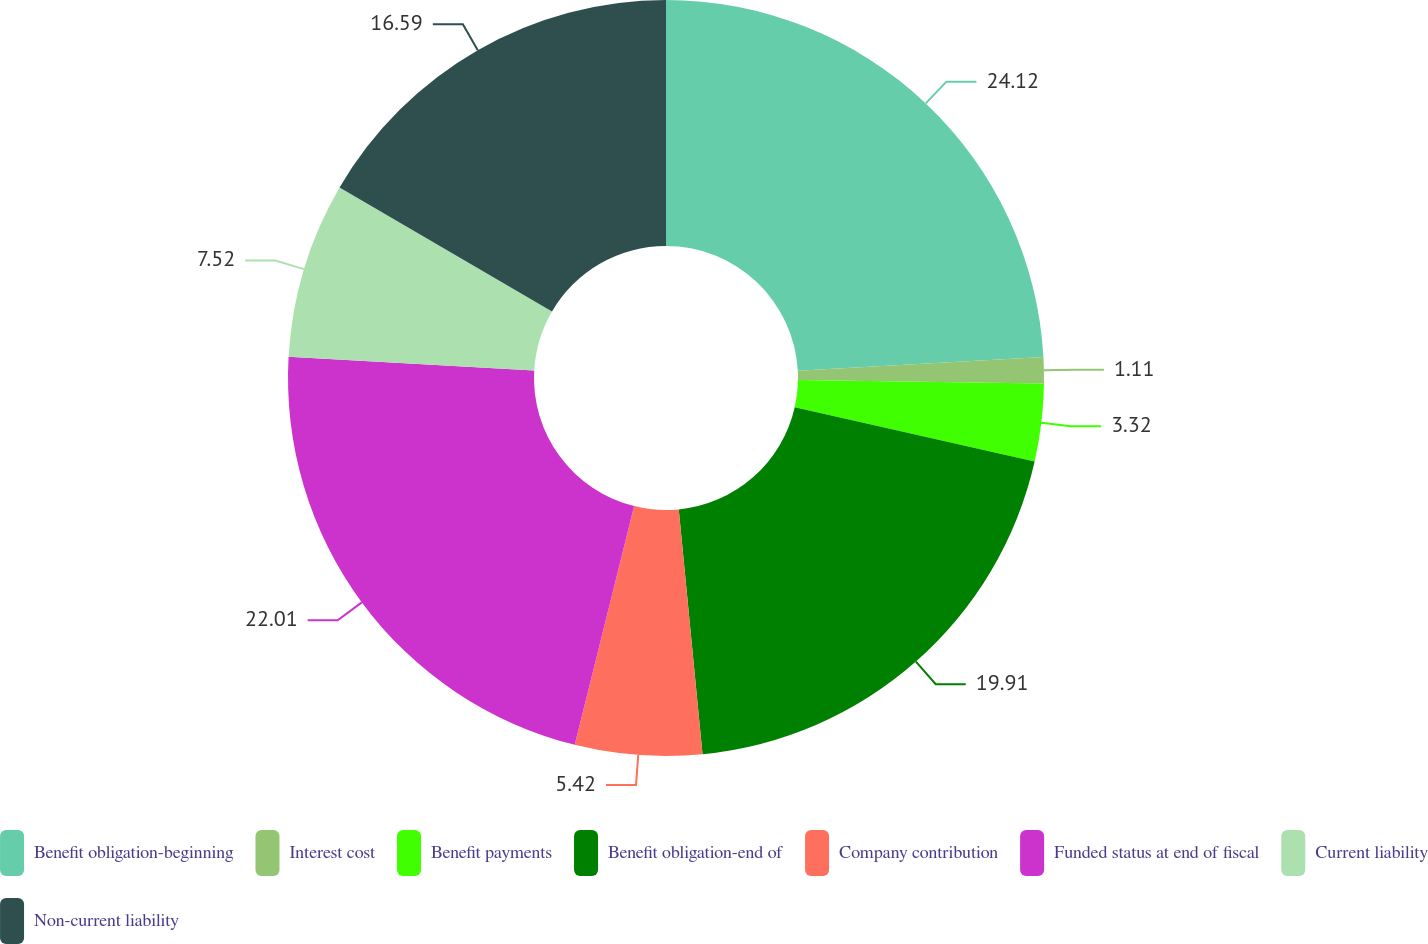Convert chart to OTSL. <chart><loc_0><loc_0><loc_500><loc_500><pie_chart><fcel>Benefit obligation-beginning<fcel>Interest cost<fcel>Benefit payments<fcel>Benefit obligation-end of<fcel>Company contribution<fcel>Funded status at end of fiscal<fcel>Current liability<fcel>Non-current liability<nl><fcel>24.12%<fcel>1.11%<fcel>3.32%<fcel>19.91%<fcel>5.42%<fcel>22.01%<fcel>7.52%<fcel>16.59%<nl></chart> 